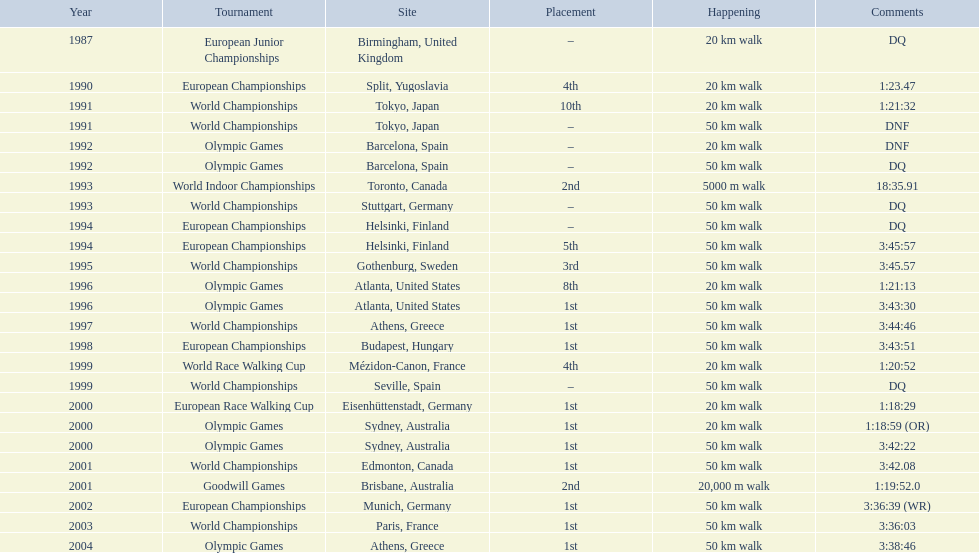Which venue is listed the most? Athens, Greece. 